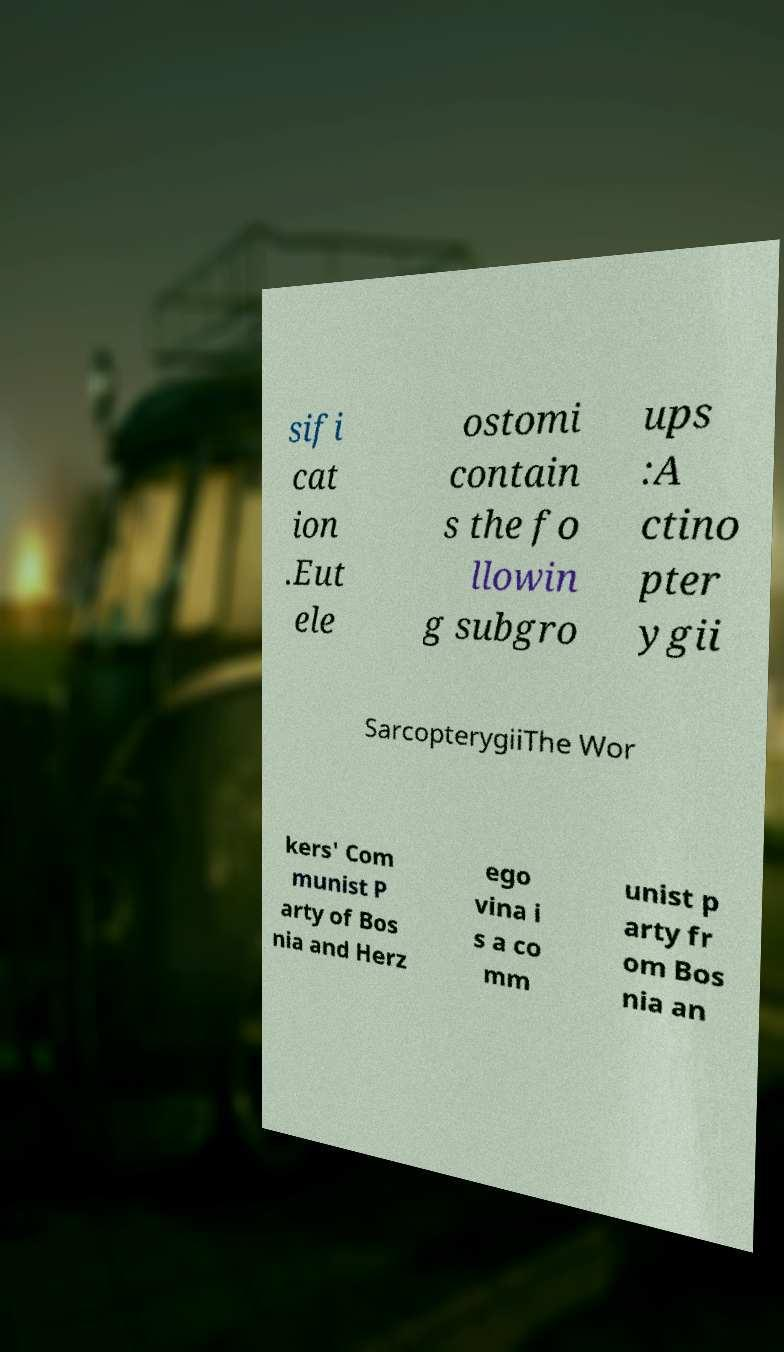For documentation purposes, I need the text within this image transcribed. Could you provide that? sifi cat ion .Eut ele ostomi contain s the fo llowin g subgro ups :A ctino pter ygii SarcopterygiiThe Wor kers' Com munist P arty of Bos nia and Herz ego vina i s a co mm unist p arty fr om Bos nia an 